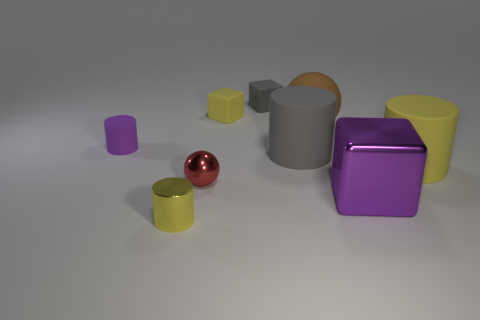Add 1 big brown rubber cylinders. How many objects exist? 10 Subtract all cubes. How many objects are left? 6 Add 6 small red shiny spheres. How many small red shiny spheres are left? 7 Add 5 metallic spheres. How many metallic spheres exist? 6 Subtract 0 brown cylinders. How many objects are left? 9 Subtract all tiny objects. Subtract all small red balls. How many objects are left? 3 